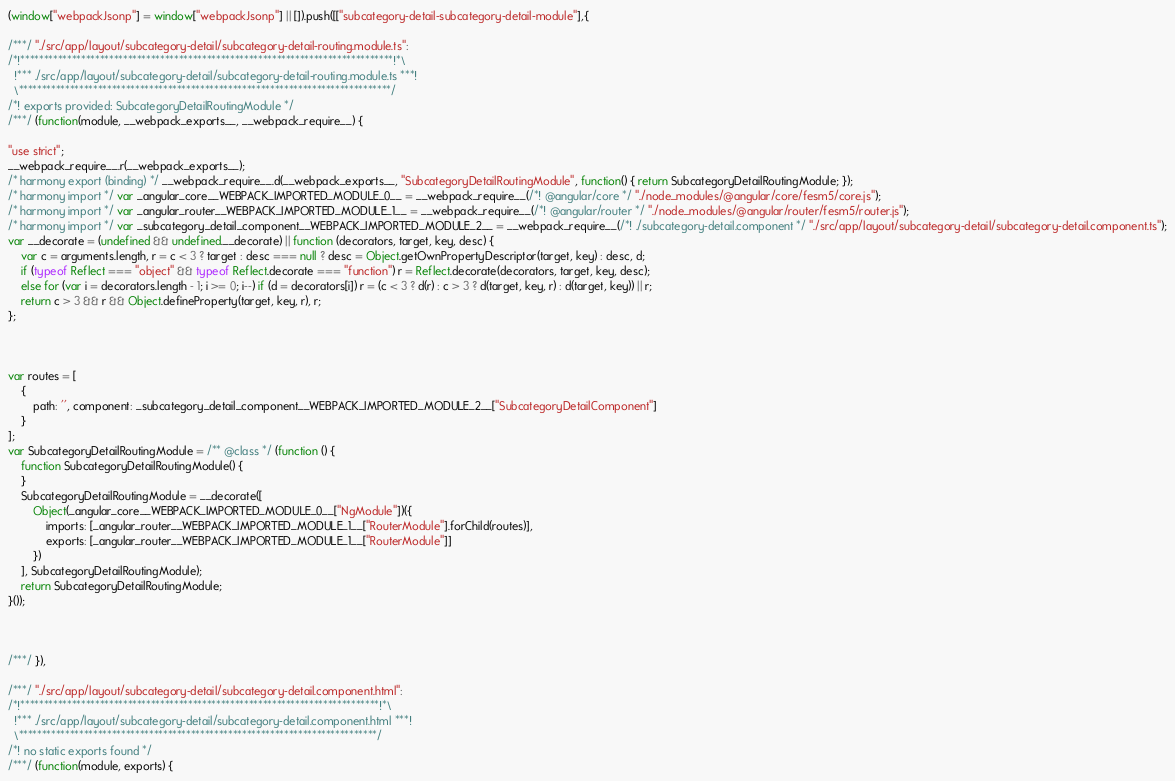<code> <loc_0><loc_0><loc_500><loc_500><_JavaScript_>(window["webpackJsonp"] = window["webpackJsonp"] || []).push([["subcategory-detail-subcategory-detail-module"],{

/***/ "./src/app/layout/subcategory-detail/subcategory-detail-routing.module.ts":
/*!********************************************************************************!*\
  !*** ./src/app/layout/subcategory-detail/subcategory-detail-routing.module.ts ***!
  \********************************************************************************/
/*! exports provided: SubcategoryDetailRoutingModule */
/***/ (function(module, __webpack_exports__, __webpack_require__) {

"use strict";
__webpack_require__.r(__webpack_exports__);
/* harmony export (binding) */ __webpack_require__.d(__webpack_exports__, "SubcategoryDetailRoutingModule", function() { return SubcategoryDetailRoutingModule; });
/* harmony import */ var _angular_core__WEBPACK_IMPORTED_MODULE_0__ = __webpack_require__(/*! @angular/core */ "./node_modules/@angular/core/fesm5/core.js");
/* harmony import */ var _angular_router__WEBPACK_IMPORTED_MODULE_1__ = __webpack_require__(/*! @angular/router */ "./node_modules/@angular/router/fesm5/router.js");
/* harmony import */ var _subcategory_detail_component__WEBPACK_IMPORTED_MODULE_2__ = __webpack_require__(/*! ./subcategory-detail.component */ "./src/app/layout/subcategory-detail/subcategory-detail.component.ts");
var __decorate = (undefined && undefined.__decorate) || function (decorators, target, key, desc) {
    var c = arguments.length, r = c < 3 ? target : desc === null ? desc = Object.getOwnPropertyDescriptor(target, key) : desc, d;
    if (typeof Reflect === "object" && typeof Reflect.decorate === "function") r = Reflect.decorate(decorators, target, key, desc);
    else for (var i = decorators.length - 1; i >= 0; i--) if (d = decorators[i]) r = (c < 3 ? d(r) : c > 3 ? d(target, key, r) : d(target, key)) || r;
    return c > 3 && r && Object.defineProperty(target, key, r), r;
};



var routes = [
    {
        path: '', component: _subcategory_detail_component__WEBPACK_IMPORTED_MODULE_2__["SubcategoryDetailComponent"]
    }
];
var SubcategoryDetailRoutingModule = /** @class */ (function () {
    function SubcategoryDetailRoutingModule() {
    }
    SubcategoryDetailRoutingModule = __decorate([
        Object(_angular_core__WEBPACK_IMPORTED_MODULE_0__["NgModule"])({
            imports: [_angular_router__WEBPACK_IMPORTED_MODULE_1__["RouterModule"].forChild(routes)],
            exports: [_angular_router__WEBPACK_IMPORTED_MODULE_1__["RouterModule"]]
        })
    ], SubcategoryDetailRoutingModule);
    return SubcategoryDetailRoutingModule;
}());



/***/ }),

/***/ "./src/app/layout/subcategory-detail/subcategory-detail.component.html":
/*!*****************************************************************************!*\
  !*** ./src/app/layout/subcategory-detail/subcategory-detail.component.html ***!
  \*****************************************************************************/
/*! no static exports found */
/***/ (function(module, exports) {
</code> 